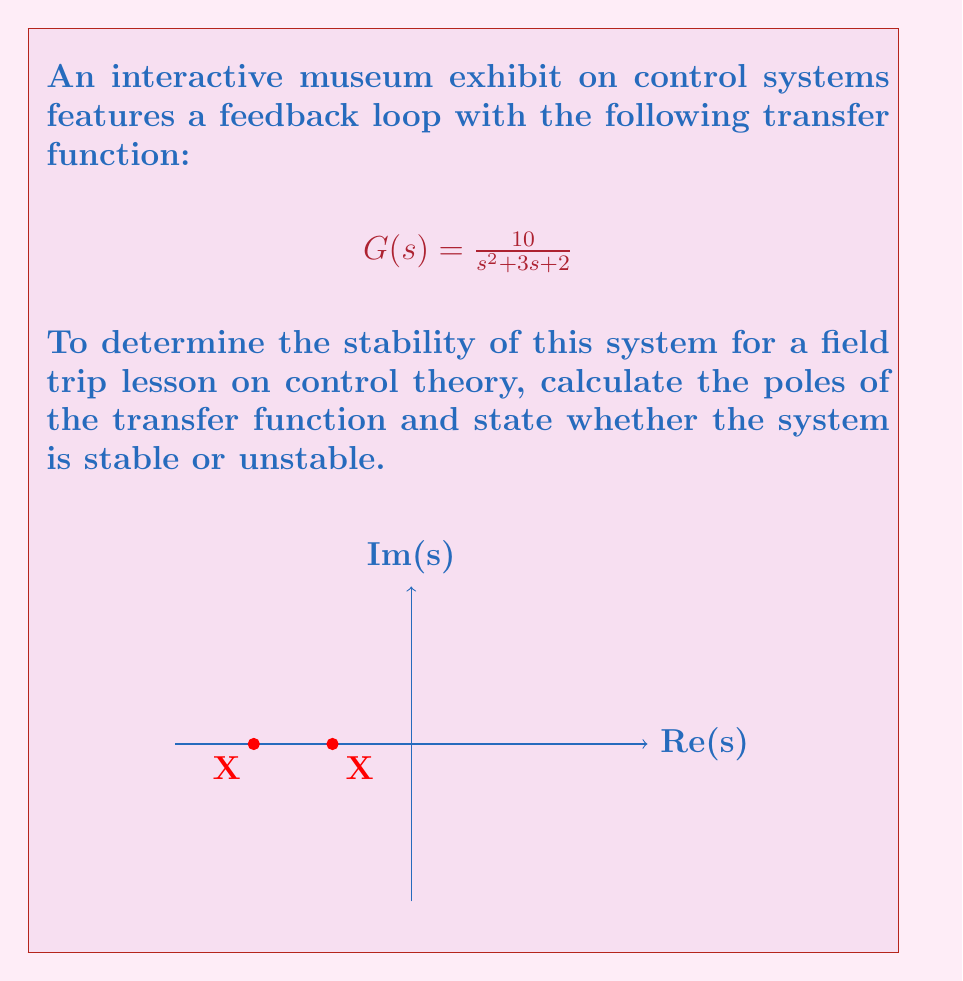Solve this math problem. To determine the stability of the feedback control system, we need to find the poles of the transfer function and analyze their location in the complex plane. The system is stable if all poles have negative real parts.

Step 1: Identify the denominator of the transfer function.
The denominator is $s^2 + 3s + 2$.

Step 2: Find the roots of the denominator equation.
$s^2 + 3s + 2 = 0$

We can solve this using the quadratic formula: $s = \frac{-b \pm \sqrt{b^2 - 4ac}}{2a}$

Where $a=1$, $b=3$, and $c=2$

$s = \frac{-3 \pm \sqrt{3^2 - 4(1)(2)}}{2(1)}$

$s = \frac{-3 \pm \sqrt{9 - 8}}{2} = \frac{-3 \pm 1}{2}$

Step 3: Calculate the poles.
$s_1 = \frac{-3 + 1}{2} = -1$
$s_2 = \frac{-3 - 1}{2} = -2$

Step 4: Analyze the poles.
Both poles (-1 and -2) are real and negative.

Step 5: Determine stability.
Since all poles have negative real parts, the system is stable.
Answer: Poles: -1 and -2; System is stable 